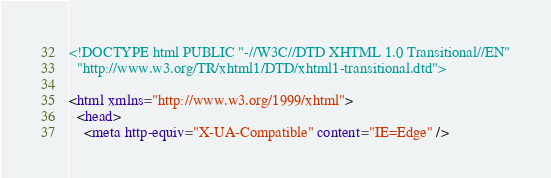Convert code to text. <code><loc_0><loc_0><loc_500><loc_500><_HTML_>
<!DOCTYPE html PUBLIC "-//W3C//DTD XHTML 1.0 Transitional//EN"
  "http://www.w3.org/TR/xhtml1/DTD/xhtml1-transitional.dtd">

<html xmlns="http://www.w3.org/1999/xhtml">
  <head>
    <meta http-equiv="X-UA-Compatible" content="IE=Edge" /></code> 